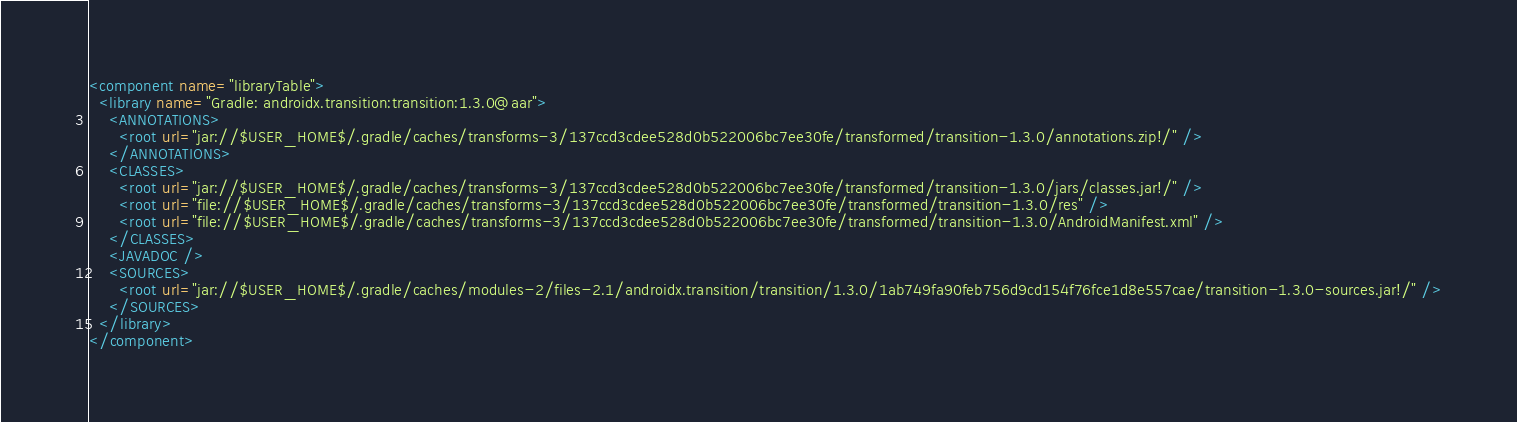<code> <loc_0><loc_0><loc_500><loc_500><_XML_><component name="libraryTable">
  <library name="Gradle: androidx.transition:transition:1.3.0@aar">
    <ANNOTATIONS>
      <root url="jar://$USER_HOME$/.gradle/caches/transforms-3/137ccd3cdee528d0b522006bc7ee30fe/transformed/transition-1.3.0/annotations.zip!/" />
    </ANNOTATIONS>
    <CLASSES>
      <root url="jar://$USER_HOME$/.gradle/caches/transforms-3/137ccd3cdee528d0b522006bc7ee30fe/transformed/transition-1.3.0/jars/classes.jar!/" />
      <root url="file://$USER_HOME$/.gradle/caches/transforms-3/137ccd3cdee528d0b522006bc7ee30fe/transformed/transition-1.3.0/res" />
      <root url="file://$USER_HOME$/.gradle/caches/transforms-3/137ccd3cdee528d0b522006bc7ee30fe/transformed/transition-1.3.0/AndroidManifest.xml" />
    </CLASSES>
    <JAVADOC />
    <SOURCES>
      <root url="jar://$USER_HOME$/.gradle/caches/modules-2/files-2.1/androidx.transition/transition/1.3.0/1ab749fa90feb756d9cd154f76fce1d8e557cae/transition-1.3.0-sources.jar!/" />
    </SOURCES>
  </library>
</component></code> 